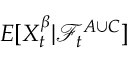<formula> <loc_0><loc_0><loc_500><loc_500>E [ X _ { t } ^ { \beta } | \mathcal { F } _ { t } ^ { A \cup C } ]</formula> 